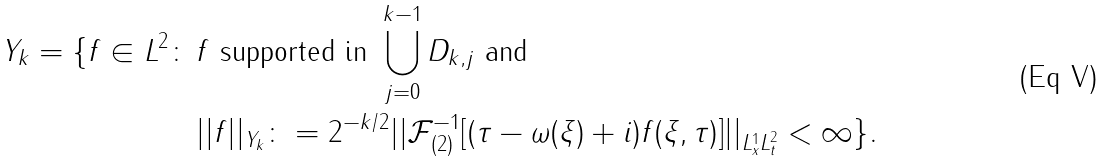<formula> <loc_0><loc_0><loc_500><loc_500>Y _ { k } = \{ f \in L ^ { 2 } \colon \, & f \text { supported in } \bigcup _ { j = 0 } ^ { k - 1 } D _ { k , j } \text { and } \\ & | | f | | _ { Y _ { k } } \colon = 2 ^ { - k / 2 } | | \mathcal { F } ^ { - 1 } _ { ( 2 ) } [ ( \tau - \omega ( \xi ) + i ) f ( \xi , \tau ) ] | | _ { L ^ { 1 } _ { x } L ^ { 2 } _ { t } } < \infty \} .</formula> 